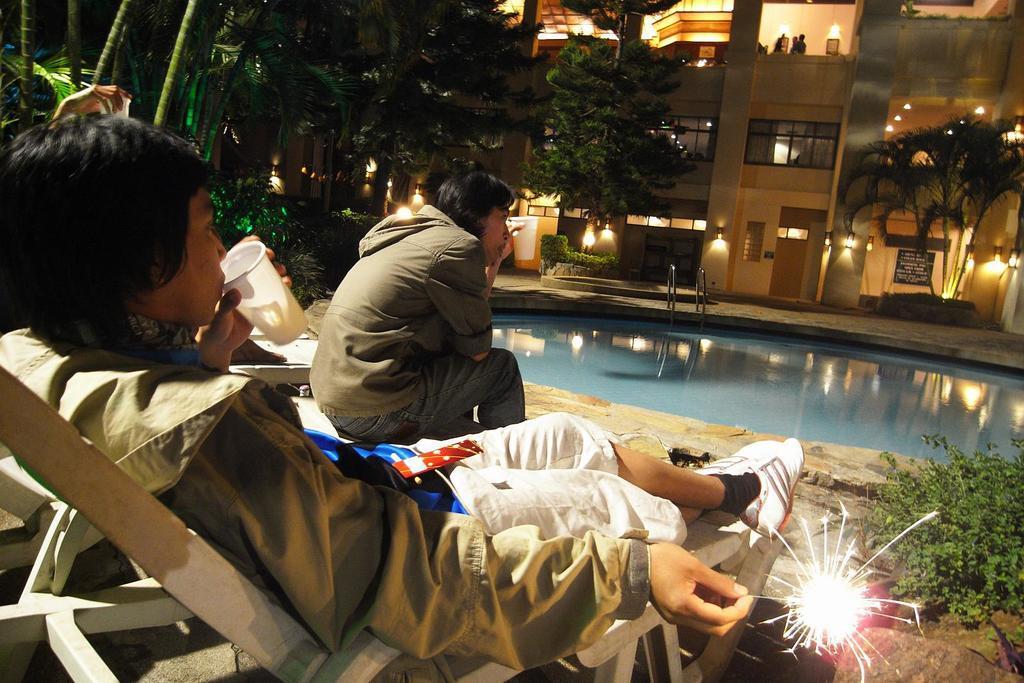Can you describe this image briefly? In the foreground I can see two persons are sitting on the chair and on the bench and holding a glass in hand. In the background I can see a swimming pool, plants, trees, buildings and a crowd. This image is taken may be in a guest house. 